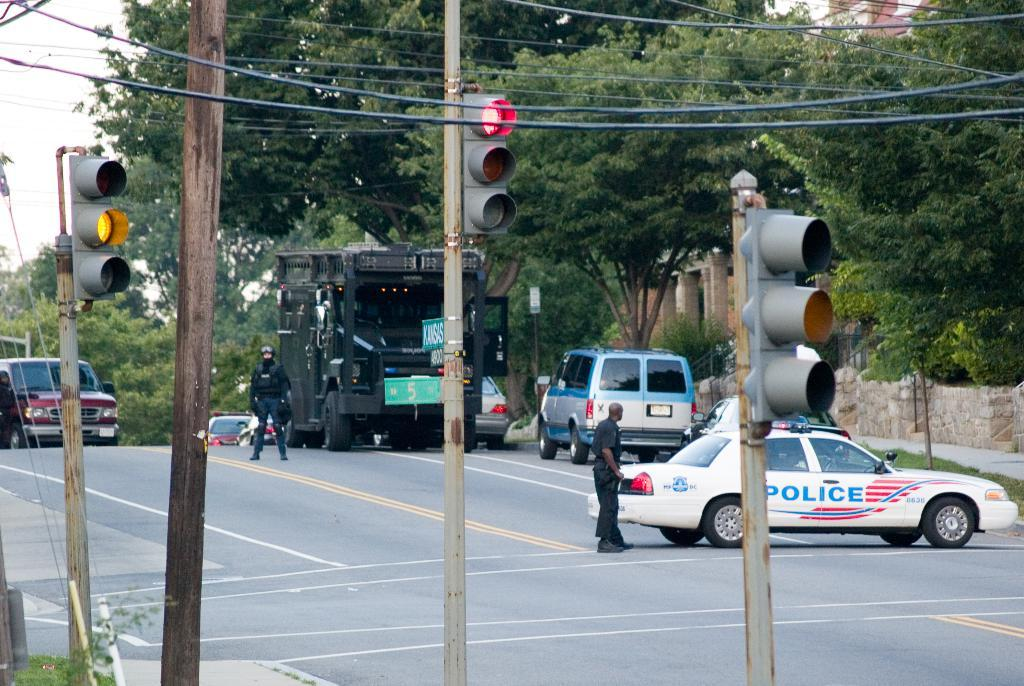Provide a one-sentence caption for the provided image. A police car blocks an intersection across a four lane highway. 